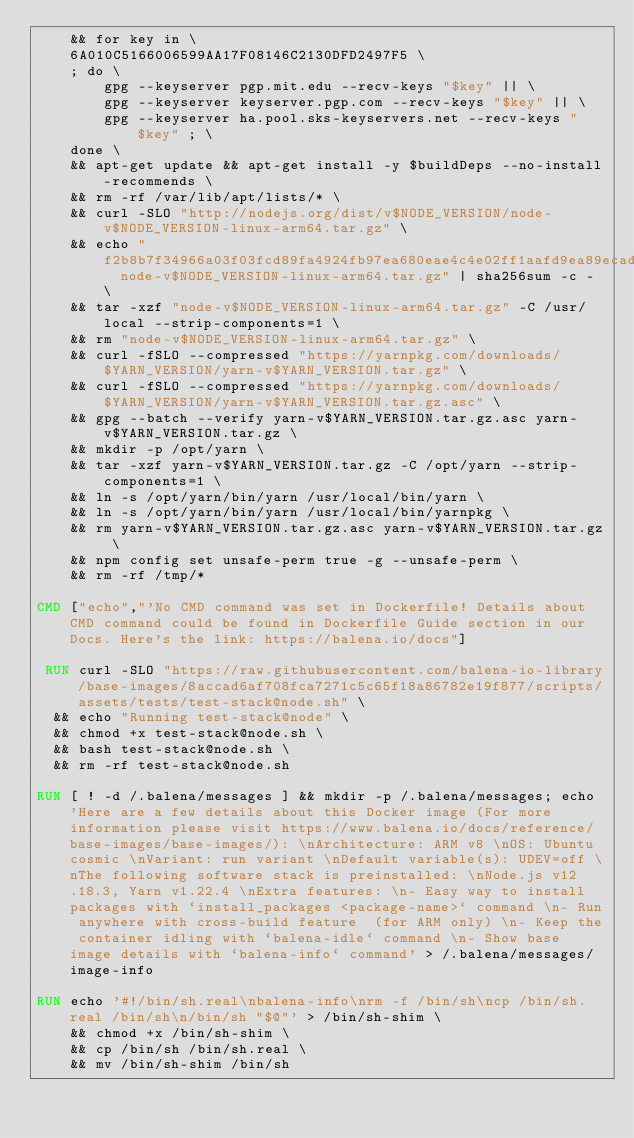Convert code to text. <code><loc_0><loc_0><loc_500><loc_500><_Dockerfile_>	&& for key in \
	6A010C5166006599AA17F08146C2130DFD2497F5 \
	; do \
		gpg --keyserver pgp.mit.edu --recv-keys "$key" || \
		gpg --keyserver keyserver.pgp.com --recv-keys "$key" || \
		gpg --keyserver ha.pool.sks-keyservers.net --recv-keys "$key" ; \
	done \
	&& apt-get update && apt-get install -y $buildDeps --no-install-recommends \
	&& rm -rf /var/lib/apt/lists/* \
	&& curl -SLO "http://nodejs.org/dist/v$NODE_VERSION/node-v$NODE_VERSION-linux-arm64.tar.gz" \
	&& echo "f2b8b7f34966a03f03fcd89fa4924fb97ea680eae4c4e02ff1aafd9ea89ecad8  node-v$NODE_VERSION-linux-arm64.tar.gz" | sha256sum -c - \
	&& tar -xzf "node-v$NODE_VERSION-linux-arm64.tar.gz" -C /usr/local --strip-components=1 \
	&& rm "node-v$NODE_VERSION-linux-arm64.tar.gz" \
	&& curl -fSLO --compressed "https://yarnpkg.com/downloads/$YARN_VERSION/yarn-v$YARN_VERSION.tar.gz" \
	&& curl -fSLO --compressed "https://yarnpkg.com/downloads/$YARN_VERSION/yarn-v$YARN_VERSION.tar.gz.asc" \
	&& gpg --batch --verify yarn-v$YARN_VERSION.tar.gz.asc yarn-v$YARN_VERSION.tar.gz \
	&& mkdir -p /opt/yarn \
	&& tar -xzf yarn-v$YARN_VERSION.tar.gz -C /opt/yarn --strip-components=1 \
	&& ln -s /opt/yarn/bin/yarn /usr/local/bin/yarn \
	&& ln -s /opt/yarn/bin/yarn /usr/local/bin/yarnpkg \
	&& rm yarn-v$YARN_VERSION.tar.gz.asc yarn-v$YARN_VERSION.tar.gz \
	&& npm config set unsafe-perm true -g --unsafe-perm \
	&& rm -rf /tmp/*

CMD ["echo","'No CMD command was set in Dockerfile! Details about CMD command could be found in Dockerfile Guide section in our Docs. Here's the link: https://balena.io/docs"]

 RUN curl -SLO "https://raw.githubusercontent.com/balena-io-library/base-images/8accad6af708fca7271c5c65f18a86782e19f877/scripts/assets/tests/test-stack@node.sh" \
  && echo "Running test-stack@node" \
  && chmod +x test-stack@node.sh \
  && bash test-stack@node.sh \
  && rm -rf test-stack@node.sh 

RUN [ ! -d /.balena/messages ] && mkdir -p /.balena/messages; echo 'Here are a few details about this Docker image (For more information please visit https://www.balena.io/docs/reference/base-images/base-images/): \nArchitecture: ARM v8 \nOS: Ubuntu cosmic \nVariant: run variant \nDefault variable(s): UDEV=off \nThe following software stack is preinstalled: \nNode.js v12.18.3, Yarn v1.22.4 \nExtra features: \n- Easy way to install packages with `install_packages <package-name>` command \n- Run anywhere with cross-build feature  (for ARM only) \n- Keep the container idling with `balena-idle` command \n- Show base image details with `balena-info` command' > /.balena/messages/image-info

RUN echo '#!/bin/sh.real\nbalena-info\nrm -f /bin/sh\ncp /bin/sh.real /bin/sh\n/bin/sh "$@"' > /bin/sh-shim \
	&& chmod +x /bin/sh-shim \
	&& cp /bin/sh /bin/sh.real \
	&& mv /bin/sh-shim /bin/sh</code> 